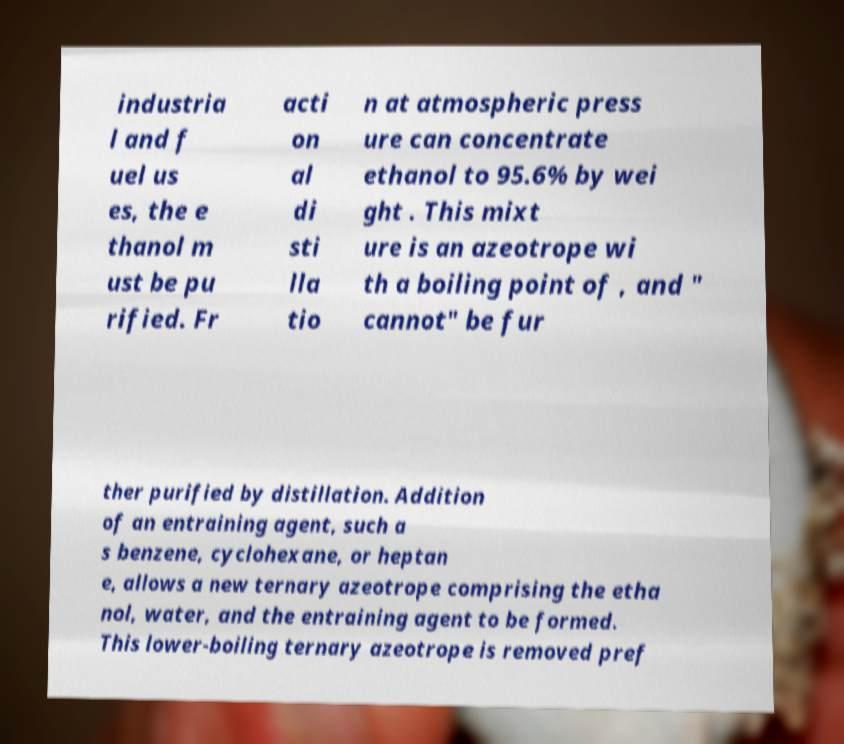Please identify and transcribe the text found in this image. industria l and f uel us es, the e thanol m ust be pu rified. Fr acti on al di sti lla tio n at atmospheric press ure can concentrate ethanol to 95.6% by wei ght . This mixt ure is an azeotrope wi th a boiling point of , and " cannot" be fur ther purified by distillation. Addition of an entraining agent, such a s benzene, cyclohexane, or heptan e, allows a new ternary azeotrope comprising the etha nol, water, and the entraining agent to be formed. This lower-boiling ternary azeotrope is removed pref 